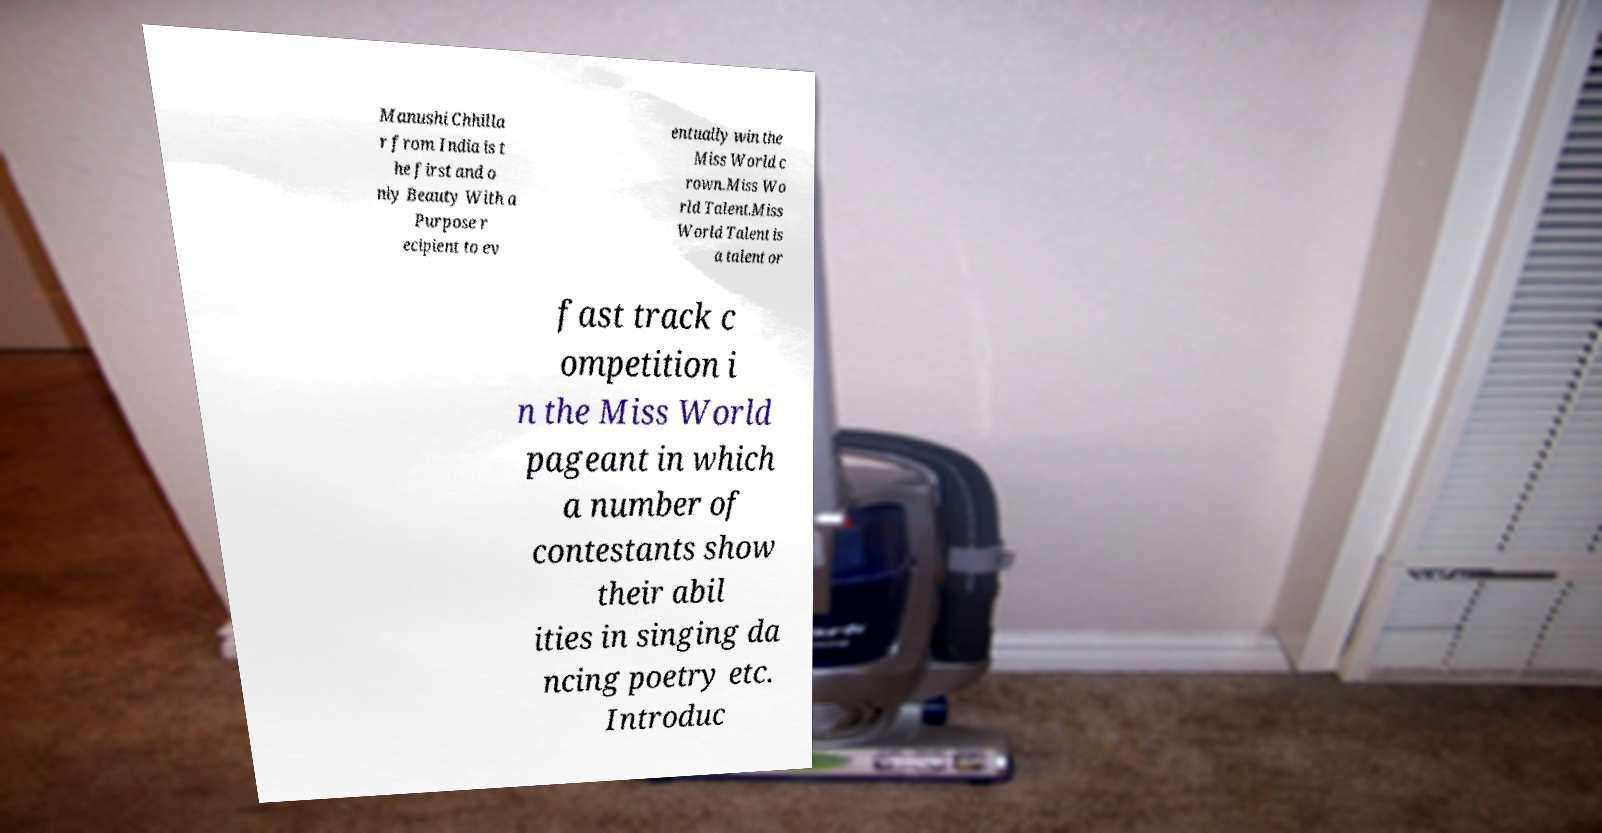Can you read and provide the text displayed in the image?This photo seems to have some interesting text. Can you extract and type it out for me? Manushi Chhilla r from India is t he first and o nly Beauty With a Purpose r ecipient to ev entually win the Miss World c rown.Miss Wo rld Talent.Miss World Talent is a talent or fast track c ompetition i n the Miss World pageant in which a number of contestants show their abil ities in singing da ncing poetry etc. Introduc 